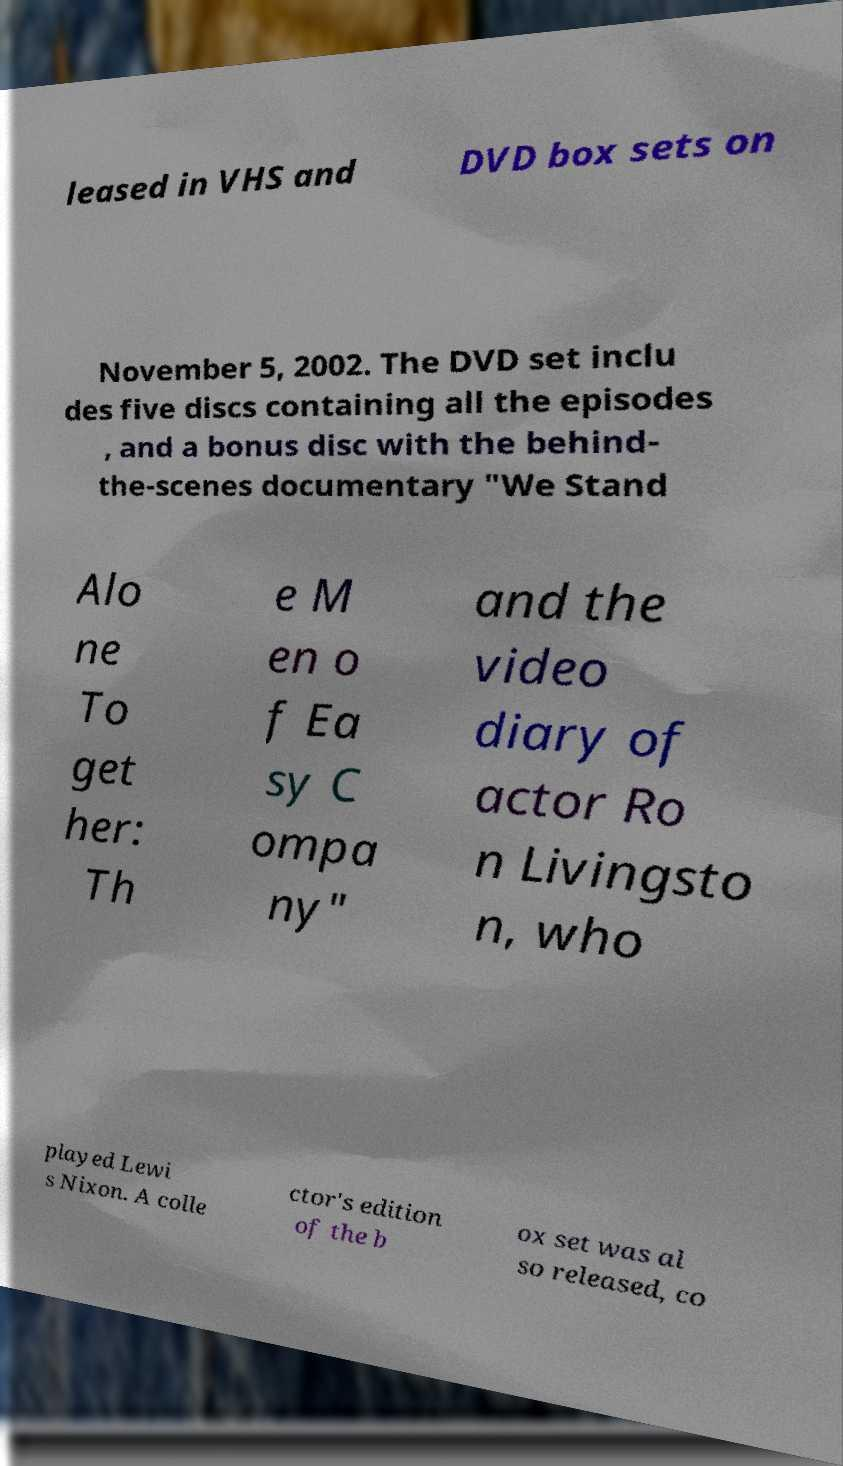Can you accurately transcribe the text from the provided image for me? leased in VHS and DVD box sets on November 5, 2002. The DVD set inclu des five discs containing all the episodes , and a bonus disc with the behind- the-scenes documentary "We Stand Alo ne To get her: Th e M en o f Ea sy C ompa ny" and the video diary of actor Ro n Livingsto n, who played Lewi s Nixon. A colle ctor's edition of the b ox set was al so released, co 